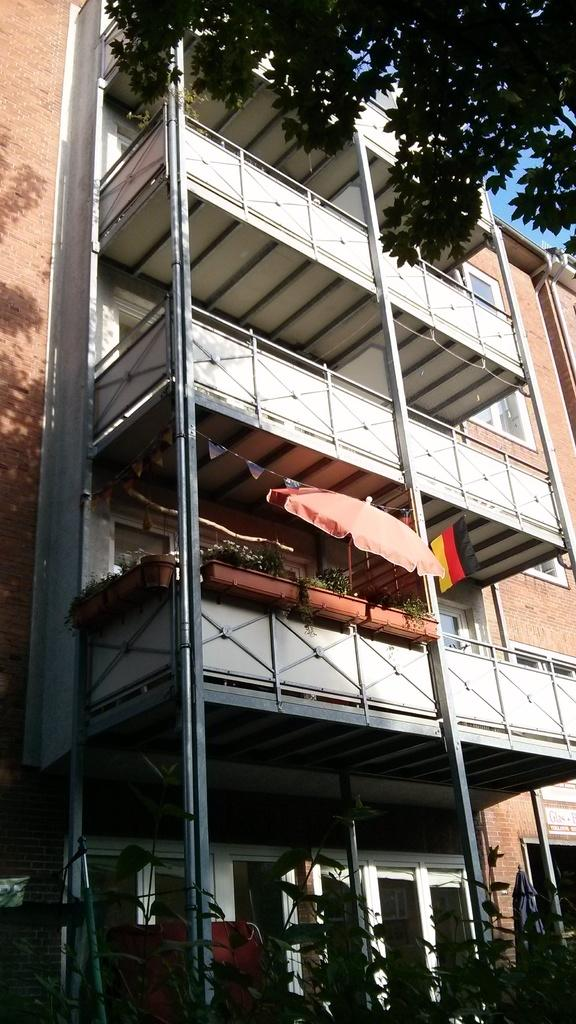What type of structure is visible in the image? There is a building in the image. What feature can be seen on the building? The building has railing. Are there any decorative elements on the building? Yes, there are potted plants, an umbrella, and flags on the building. What can be seen in front of the building? Trees are visible in front of the building. What type of shoes can be seen on the toes of the building in the image? There are no shoes or toes present on the building in the image. 